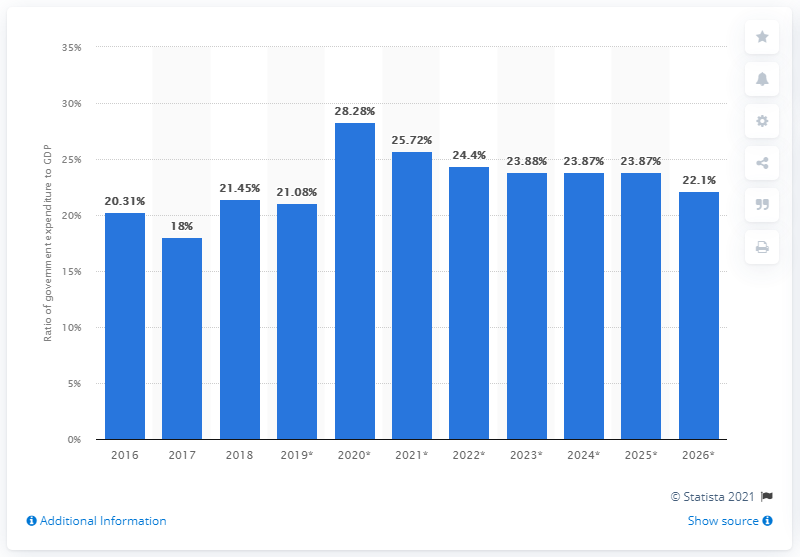List a handful of essential elements in this visual. In 2018, the ratio of government expenditure to gross domestic product changed. In 2018, government expenditure accounted for 21.45% of Ghana's GDP. 